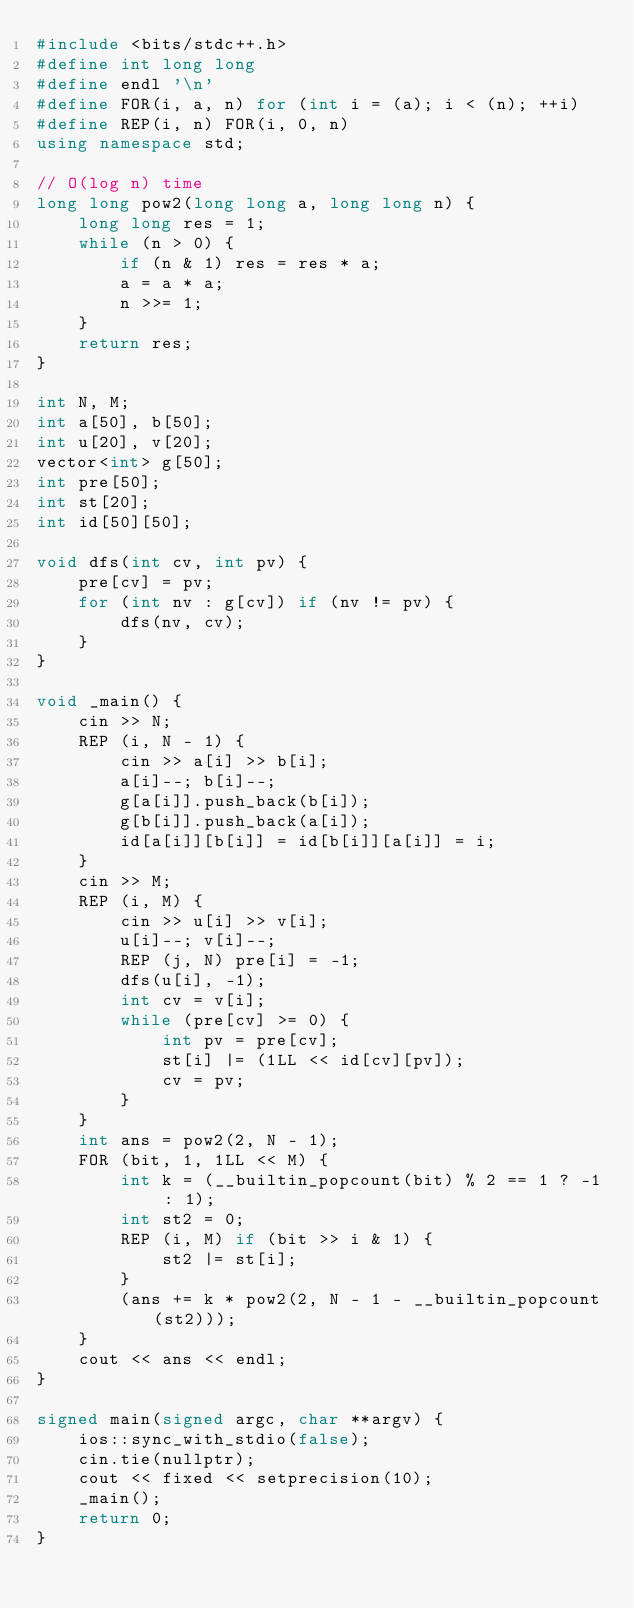<code> <loc_0><loc_0><loc_500><loc_500><_C++_>#include <bits/stdc++.h>
#define int long long
#define endl '\n'
#define FOR(i, a, n) for (int i = (a); i < (n); ++i)
#define REP(i, n) FOR(i, 0, n)
using namespace std;

// O(log n) time
long long pow2(long long a, long long n) {
    long long res = 1;
    while (n > 0) {
        if (n & 1) res = res * a;
        a = a * a;
        n >>= 1;
    }
    return res;
}

int N, M;
int a[50], b[50];
int u[20], v[20];
vector<int> g[50];
int pre[50];
int st[20];
int id[50][50];

void dfs(int cv, int pv) {
    pre[cv] = pv;
    for (int nv : g[cv]) if (nv != pv) {
        dfs(nv, cv);
    }
}

void _main() {
    cin >> N;
    REP (i, N - 1) {
        cin >> a[i] >> b[i];
        a[i]--; b[i]--;
        g[a[i]].push_back(b[i]);
        g[b[i]].push_back(a[i]);
        id[a[i]][b[i]] = id[b[i]][a[i]] = i;
    }
    cin >> M;
    REP (i, M) {
        cin >> u[i] >> v[i];
        u[i]--; v[i]--;
        REP (j, N) pre[i] = -1;
        dfs(u[i], -1);
        int cv = v[i];
        while (pre[cv] >= 0) {
            int pv = pre[cv];
            st[i] |= (1LL << id[cv][pv]);
            cv = pv;
        }
    }
    int ans = pow2(2, N - 1);
    FOR (bit, 1, 1LL << M) {
        int k = (__builtin_popcount(bit) % 2 == 1 ? -1 : 1);
        int st2 = 0;
        REP (i, M) if (bit >> i & 1) {
            st2 |= st[i];
        }
        (ans += k * pow2(2, N - 1 - __builtin_popcount(st2)));
    }
    cout << ans << endl;
}

signed main(signed argc, char **argv) {
    ios::sync_with_stdio(false);
    cin.tie(nullptr);
    cout << fixed << setprecision(10);
    _main();
    return 0;
}</code> 